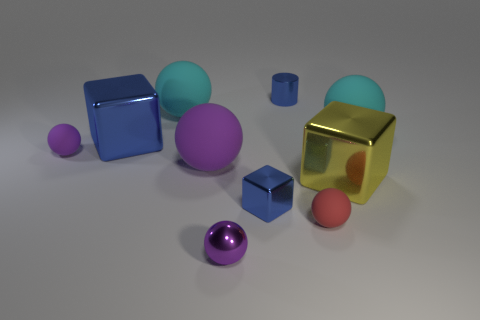Subtract all purple balls. How many were subtracted if there are1purple balls left? 2 Subtract all blue cubes. How many cubes are left? 1 Subtract all cyan blocks. How many purple balls are left? 3 Subtract all purple balls. How many balls are left? 3 Subtract 2 balls. How many balls are left? 4 Subtract all gray spheres. Subtract all blue blocks. How many spheres are left? 6 Add 9 tiny yellow metal balls. How many tiny yellow metal balls exist? 9 Subtract 1 blue cylinders. How many objects are left? 9 Subtract all blocks. How many objects are left? 7 Subtract all small metallic objects. Subtract all small purple matte balls. How many objects are left? 6 